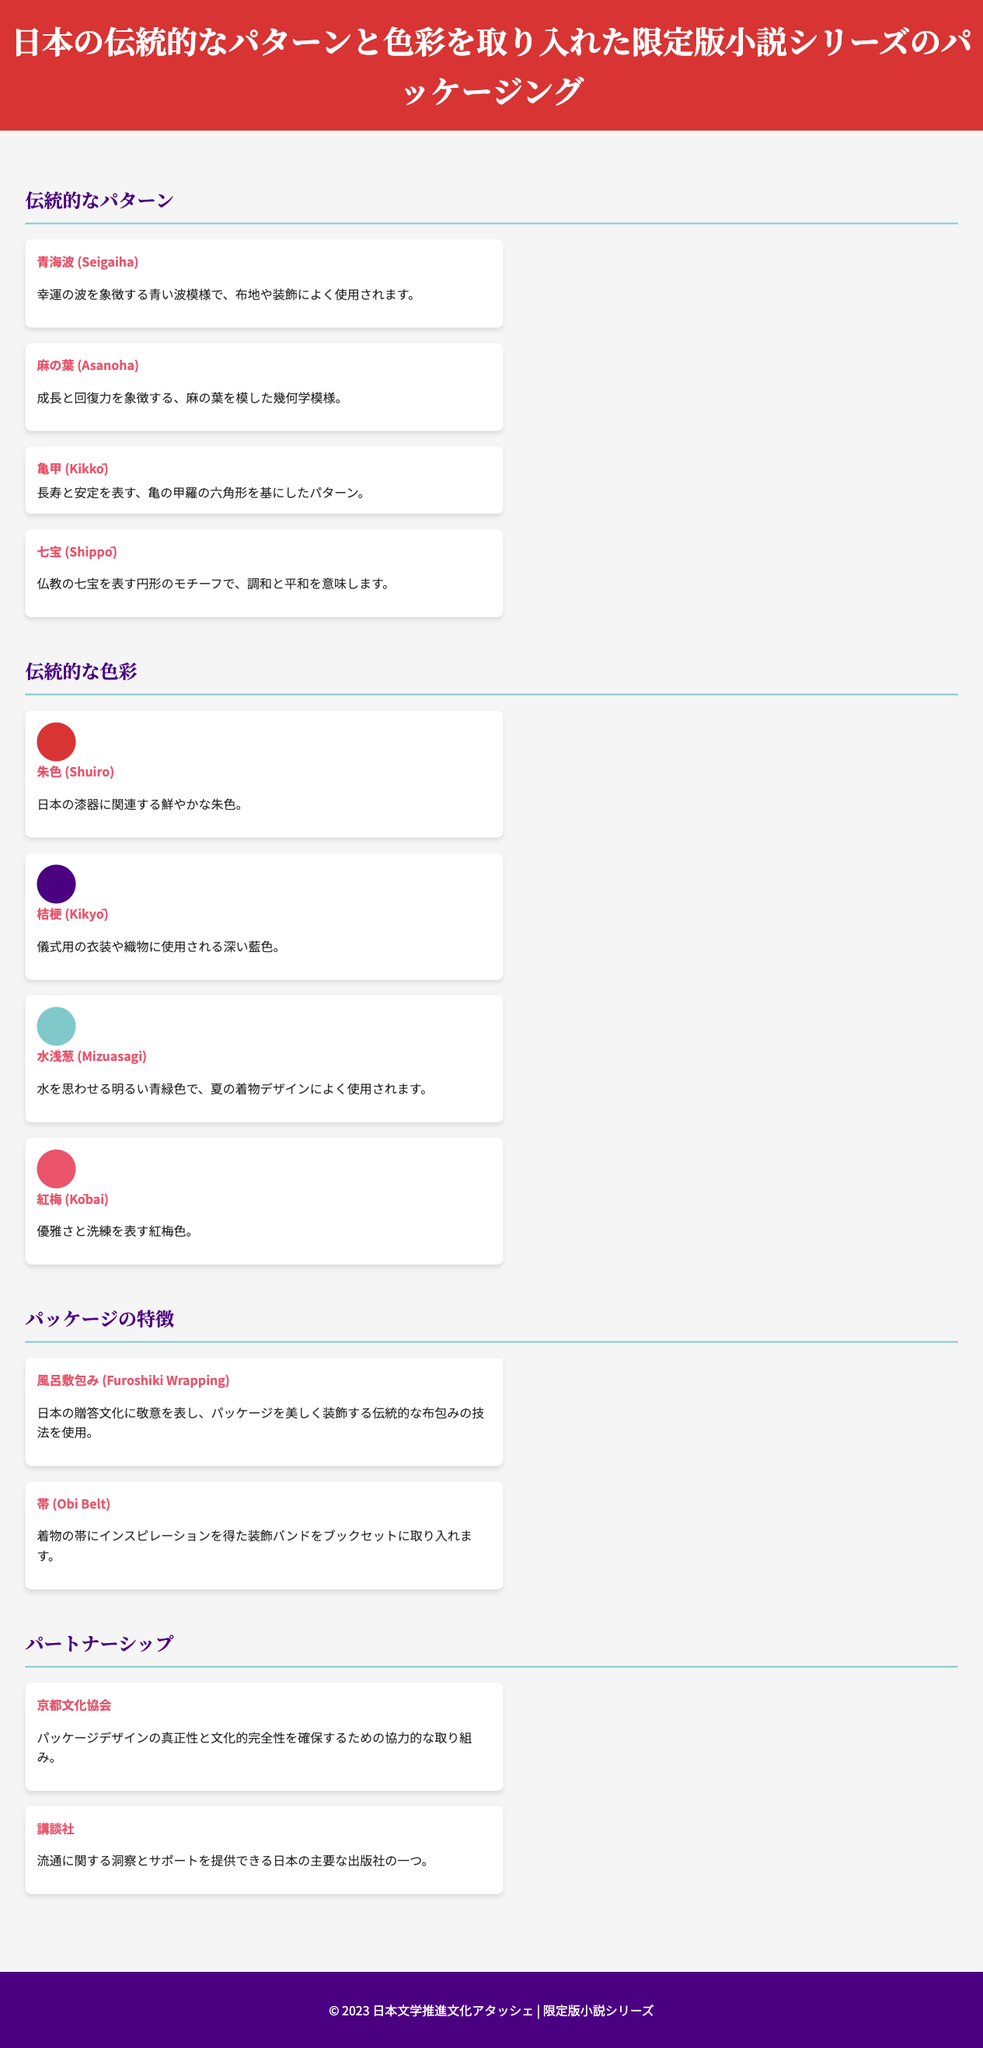what is the title of the packaging document? The title of the packaging document is prominently displayed in the header.
Answer: 日本の伝統的なパターンと色彩を取り入れた限定版小説シリーズのパッケージング how many traditional patterns are listed? The document provides a section specifically detailing traditional patterns, which includes four distinct patterns.
Answer: 4 what is the color associated with 藤色? The color associated with 藤色 is not explicitly listed; we are only given the colors mentioned in the document.
Answer: Not applicable which pattern symbolizes longevity and stability? The pattern described in the document that represents longevity and stability is explicitly identified in the traditional patterns section.
Answer: 亀甲 (Kikkō) who is one of the partners mentioned in the document? The partnerships section lists two organizations that are involved, highlighting their role in the packaging project.
Answer: 京都文化協会 what type of wrapping technique is used in the packaging? The packaging document mentions a traditional wrapping technique that ties into Japanese gift culture, emphasizing its significance.
Answer: 風呂敷包み (Furoshiki Wrapping) what does the color 水浅葱 represent? The document describes the meaning related to the color 水浅葱, which is used in summer kimono designs.
Answer: 水を思わせる明るい青緑色 how is the book set decorated? The document specifies a detail about the decoration inspired by a traditional garment that is incorporated into the book set.
Answer: 帯 (Obi Belt) 